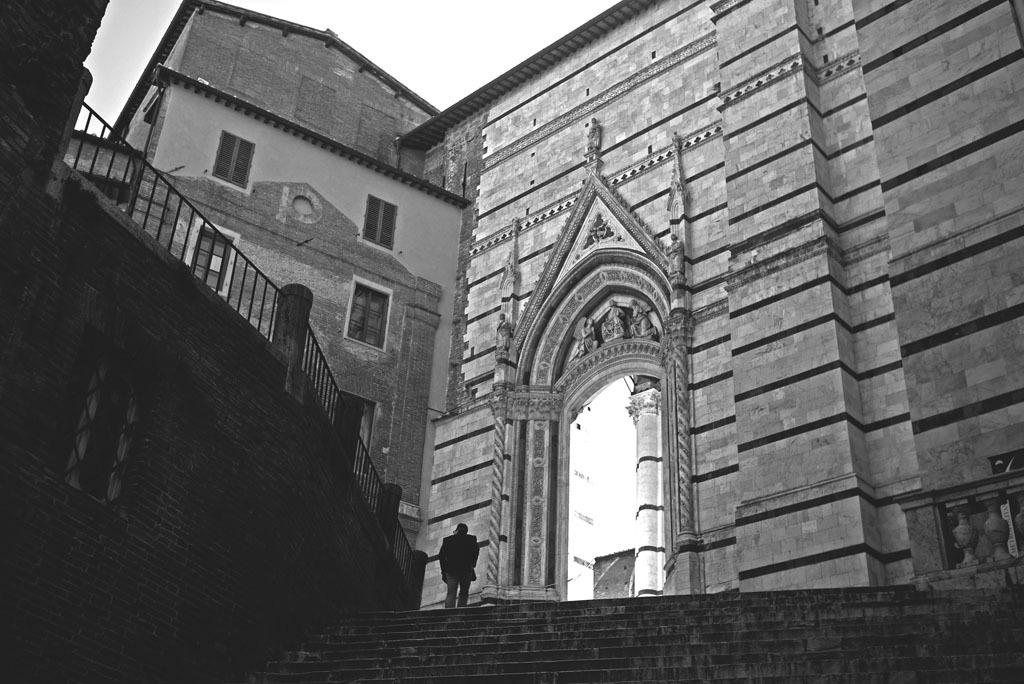What is the main subject of the image? There is a man standing in the image. Where is the man located in the image? The man is standing on stairs. What structure is visible in the background of the image? There is a building in the image. How would you describe the weather based on the image? The sky is cloudy in the image. What type of knife is the man holding in the image? There is no knife present in the image; the man is not holding any object. What disease is the man suffering from in the image? There is no indication of any disease in the image; the man appears to be standing normally on the stairs. 